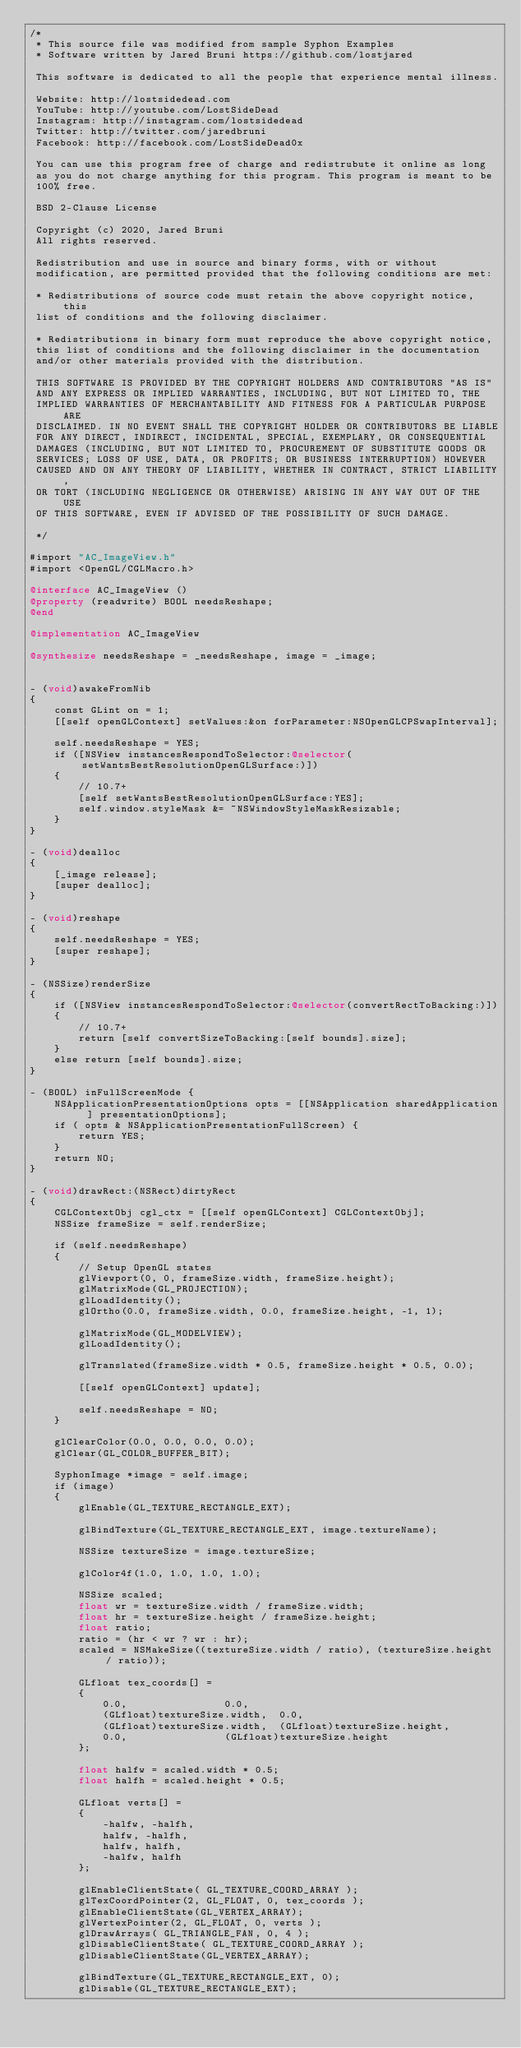<code> <loc_0><loc_0><loc_500><loc_500><_ObjectiveC_>/*
 * This source file was modified from sample Syphon Examples
 * Software written by Jared Bruni https://github.com/lostjared
 
 This software is dedicated to all the people that experience mental illness.
 
 Website: http://lostsidedead.com
 YouTube: http://youtube.com/LostSideDead
 Instagram: http://instagram.com/lostsidedead
 Twitter: http://twitter.com/jaredbruni
 Facebook: http://facebook.com/LostSideDead0x
 
 You can use this program free of charge and redistrubute it online as long
 as you do not charge anything for this program. This program is meant to be
 100% free.
 
 BSD 2-Clause License
 
 Copyright (c) 2020, Jared Bruni
 All rights reserved.
 
 Redistribution and use in source and binary forms, with or without
 modification, are permitted provided that the following conditions are met:
 
 * Redistributions of source code must retain the above copyright notice, this
 list of conditions and the following disclaimer.
 
 * Redistributions in binary form must reproduce the above copyright notice,
 this list of conditions and the following disclaimer in the documentation
 and/or other materials provided with the distribution.
 
 THIS SOFTWARE IS PROVIDED BY THE COPYRIGHT HOLDERS AND CONTRIBUTORS "AS IS"
 AND ANY EXPRESS OR IMPLIED WARRANTIES, INCLUDING, BUT NOT LIMITED TO, THE
 IMPLIED WARRANTIES OF MERCHANTABILITY AND FITNESS FOR A PARTICULAR PURPOSE ARE
 DISCLAIMED. IN NO EVENT SHALL THE COPYRIGHT HOLDER OR CONTRIBUTORS BE LIABLE
 FOR ANY DIRECT, INDIRECT, INCIDENTAL, SPECIAL, EXEMPLARY, OR CONSEQUENTIAL
 DAMAGES (INCLUDING, BUT NOT LIMITED TO, PROCUREMENT OF SUBSTITUTE GOODS OR
 SERVICES; LOSS OF USE, DATA, OR PROFITS; OR BUSINESS INTERRUPTION) HOWEVER
 CAUSED AND ON ANY THEORY OF LIABILITY, WHETHER IN CONTRACT, STRICT LIABILITY,
 OR TORT (INCLUDING NEGLIGENCE OR OTHERWISE) ARISING IN ANY WAY OUT OF THE USE
 OF THIS SOFTWARE, EVEN IF ADVISED OF THE POSSIBILITY OF SUCH DAMAGE.
 
 */

#import "AC_ImageView.h"
#import <OpenGL/CGLMacro.h>

@interface AC_ImageView ()
@property (readwrite) BOOL needsReshape;
@end

@implementation AC_ImageView

@synthesize needsReshape = _needsReshape, image = _image;


- (void)awakeFromNib
{
    const GLint on = 1;
    [[self openGLContext] setValues:&on forParameter:NSOpenGLCPSwapInterval];
    
    self.needsReshape = YES;
    if ([NSView instancesRespondToSelector:@selector(setWantsBestResolutionOpenGLSurface:)])
    {
        // 10.7+
        [self setWantsBestResolutionOpenGLSurface:YES];
        self.window.styleMask &= ~NSWindowStyleMaskResizable;
    }
}

- (void)dealloc
{
    [_image release];
    [super dealloc];
}

- (void)reshape
{
    self.needsReshape = YES;
    [super reshape];
}

- (NSSize)renderSize
{
    if ([NSView instancesRespondToSelector:@selector(convertRectToBacking:)])
    {
        // 10.7+
        return [self convertSizeToBacking:[self bounds].size];
    }
    else return [self bounds].size;
}

- (BOOL) inFullScreenMode {
    NSApplicationPresentationOptions opts = [[NSApplication sharedApplication ] presentationOptions];
    if ( opts & NSApplicationPresentationFullScreen) {
        return YES;
    }
    return NO;
}

- (void)drawRect:(NSRect)dirtyRect
{
    CGLContextObj cgl_ctx = [[self openGLContext] CGLContextObj];
    NSSize frameSize = self.renderSize;
    
    if (self.needsReshape)
    {
        // Setup OpenGL states
        glViewport(0, 0, frameSize.width, frameSize.height);        
        glMatrixMode(GL_PROJECTION);
        glLoadIdentity();
        glOrtho(0.0, frameSize.width, 0.0, frameSize.height, -1, 1);
        
        glMatrixMode(GL_MODELVIEW);
        glLoadIdentity();
        
        glTranslated(frameSize.width * 0.5, frameSize.height * 0.5, 0.0);
        
        [[self openGLContext] update];
        
        self.needsReshape = NO;
    }
    
    glClearColor(0.0, 0.0, 0.0, 0.0);
    glClear(GL_COLOR_BUFFER_BIT);
    
    SyphonImage *image = self.image;
    if (image)
    {
        glEnable(GL_TEXTURE_RECTANGLE_EXT);
        
        glBindTexture(GL_TEXTURE_RECTANGLE_EXT, image.textureName);
        
        NSSize textureSize = image.textureSize;
        
        glColor4f(1.0, 1.0, 1.0, 1.0);
        
        NSSize scaled;
        float wr = textureSize.width / frameSize.width;
        float hr = textureSize.height / frameSize.height;
        float ratio;
        ratio = (hr < wr ? wr : hr);
        scaled = NSMakeSize((textureSize.width / ratio), (textureSize.height / ratio));
        
        GLfloat tex_coords[] =
        {
            0.0,                0.0,
            (GLfloat)textureSize.width,  0.0,
            (GLfloat)textureSize.width,  (GLfloat)textureSize.height,
            0.0,                (GLfloat)textureSize.height
        };
        
        float halfw = scaled.width * 0.5;
        float halfh = scaled.height * 0.5;
        
        GLfloat verts[] =
        {
            -halfw, -halfh,
            halfw, -halfh,
            halfw, halfh,
            -halfw, halfh
        };
        
        glEnableClientState( GL_TEXTURE_COORD_ARRAY );
        glTexCoordPointer(2, GL_FLOAT, 0, tex_coords );
        glEnableClientState(GL_VERTEX_ARRAY);
        glVertexPointer(2, GL_FLOAT, 0, verts );
        glDrawArrays( GL_TRIANGLE_FAN, 0, 4 );
        glDisableClientState( GL_TEXTURE_COORD_ARRAY );
        glDisableClientState(GL_VERTEX_ARRAY);
        
        glBindTexture(GL_TEXTURE_RECTANGLE_EXT, 0);
        glDisable(GL_TEXTURE_RECTANGLE_EXT);</code> 